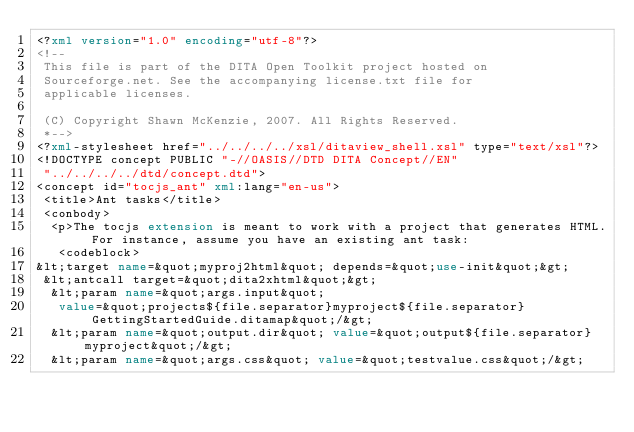Convert code to text. <code><loc_0><loc_0><loc_500><loc_500><_XML_><?xml version="1.0" encoding="utf-8"?>
<!-- 
 This file is part of the DITA Open Toolkit project hosted on
 Sourceforge.net. See the accompanying license.txt file for
 applicable licenses.
 
 (C) Copyright Shawn McKenzie, 2007. All Rights Reserved.
 *-->
<?xml-stylesheet href="../../../../xsl/ditaview_shell.xsl" type="text/xsl"?>
<!DOCTYPE concept PUBLIC "-//OASIS//DTD DITA Concept//EN"
 "../../../../dtd/concept.dtd">
<concept id="tocjs_ant" xml:lang="en-us">
 <title>Ant tasks</title>
 <conbody>
  <p>The tocjs extension is meant to work with a project that generates HTML. For instance, assume you have an existing ant task:
   <codeblock>
&lt;target name=&quot;myproj2html&quot; depends=&quot;use-init&quot;&gt;
 &lt;antcall target=&quot;dita2xhtml&quot;&gt;
  &lt;param name=&quot;args.input&quot;
   value=&quot;projects${file.separator}myproject${file.separator}GettingStartedGuide.ditamap&quot;/&gt;
  &lt;param name=&quot;output.dir&quot; value=&quot;output${file.separator}myproject&quot;/&gt;
  &lt;param name=&quot;args.css&quot; value=&quot;testvalue.css&quot;/&gt;</code> 